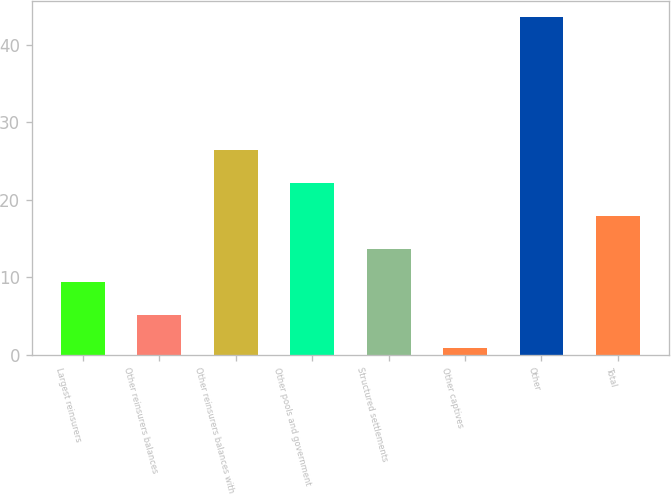<chart> <loc_0><loc_0><loc_500><loc_500><bar_chart><fcel>Largest reinsurers<fcel>Other reinsurers balances<fcel>Other reinsurers balances with<fcel>Other pools and government<fcel>Structured settlements<fcel>Other captives<fcel>Other<fcel>Total<nl><fcel>9.42<fcel>5.16<fcel>26.46<fcel>22.2<fcel>13.68<fcel>0.9<fcel>43.5<fcel>17.94<nl></chart> 